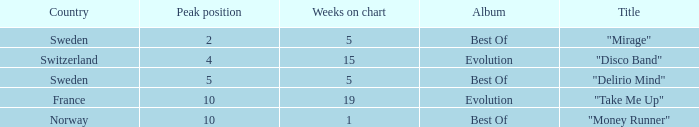What is the country with the album best of and weeks on chart is less than 5? Norway. 